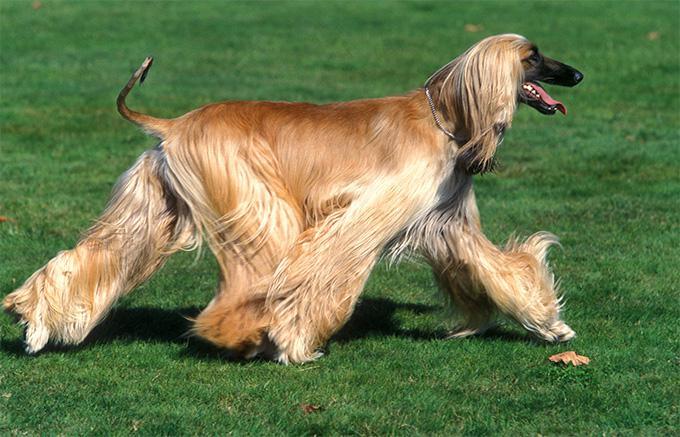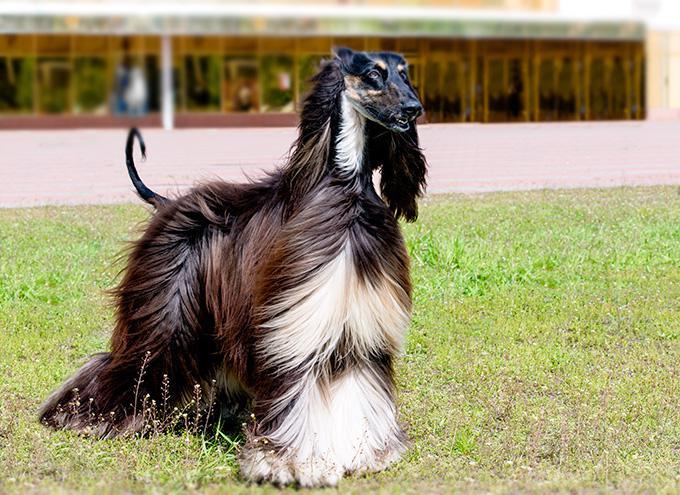The first image is the image on the left, the second image is the image on the right. Evaluate the accuracy of this statement regarding the images: "One image is a standing dog and one is a dog's head.". Is it true? Answer yes or no. No. The first image is the image on the left, the second image is the image on the right. For the images displayed, is the sentence "There is a headshot of a long haired dog." factually correct? Answer yes or no. No. 